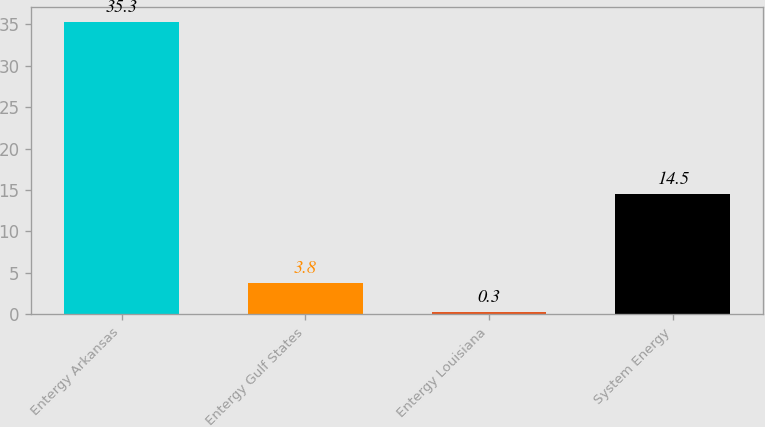Convert chart to OTSL. <chart><loc_0><loc_0><loc_500><loc_500><bar_chart><fcel>Entergy Arkansas<fcel>Entergy Gulf States<fcel>Entergy Louisiana<fcel>System Energy<nl><fcel>35.3<fcel>3.8<fcel>0.3<fcel>14.5<nl></chart> 